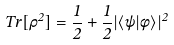<formula> <loc_0><loc_0><loc_500><loc_500>T r [ \rho ^ { 2 } ] = \frac { 1 } { 2 } + \frac { 1 } { 2 } | \langle \psi | \phi \rangle | ^ { 2 }</formula> 